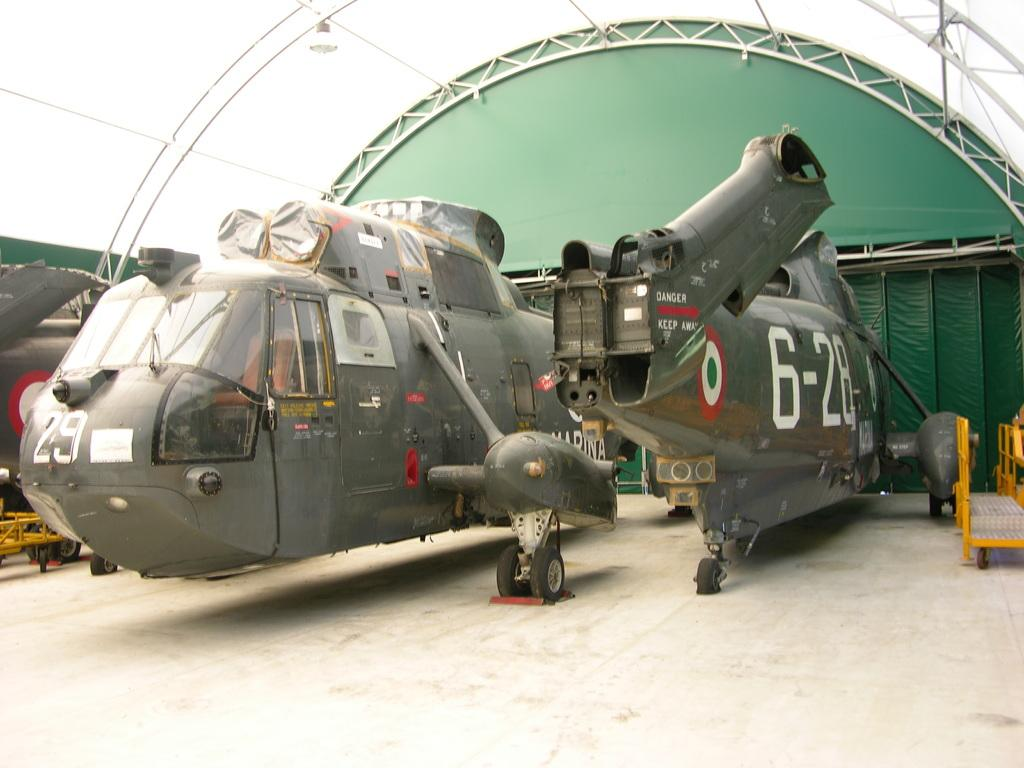<image>
Summarize the visual content of the image. Military helicopter number 29 is sitting in a hangar. 